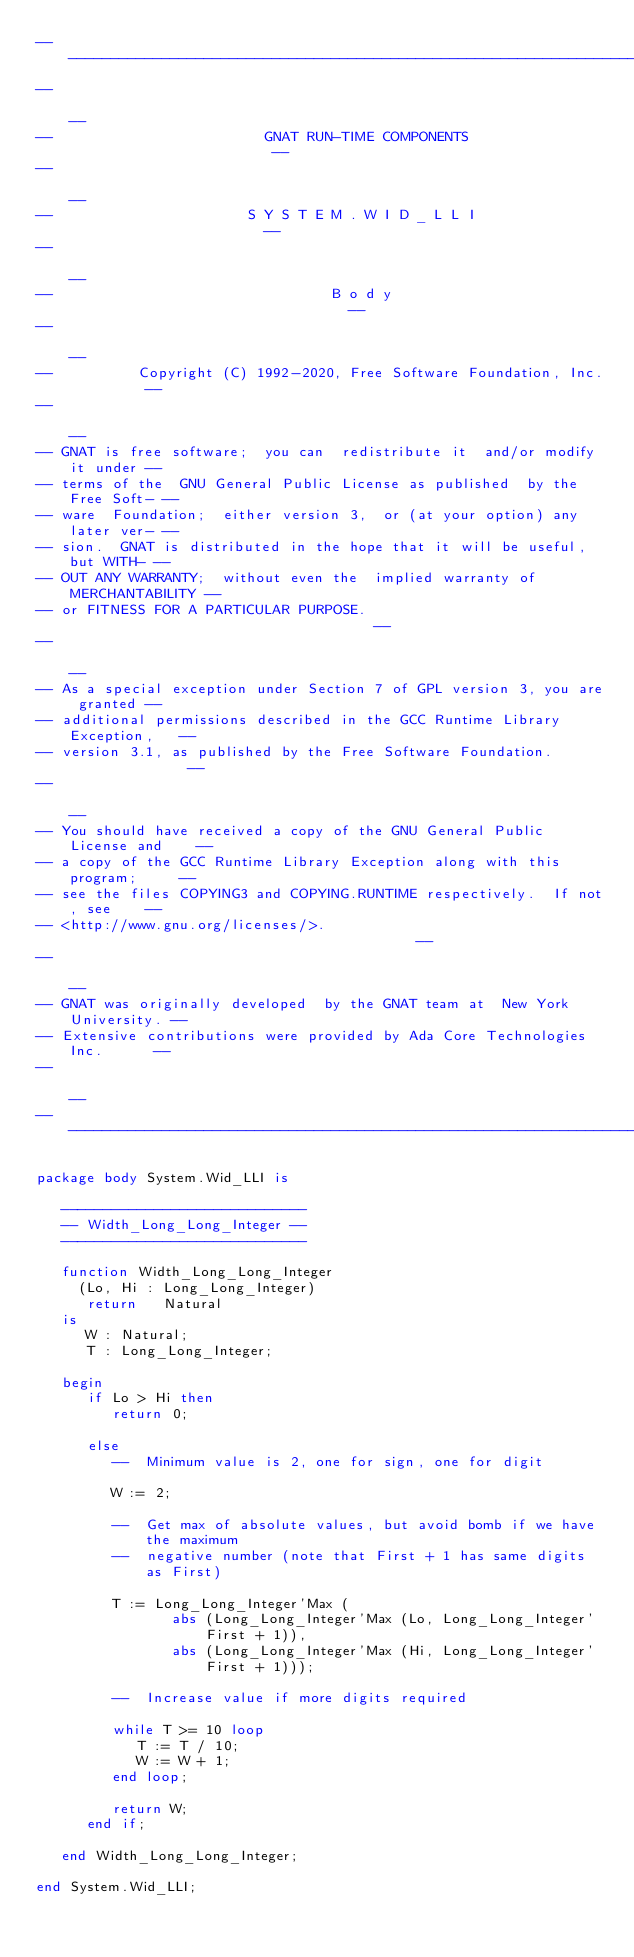Convert code to text. <code><loc_0><loc_0><loc_500><loc_500><_Ada_>------------------------------------------------------------------------------
--                                                                          --
--                         GNAT RUN-TIME COMPONENTS                         --
--                                                                          --
--                       S Y S T E M . W I D _ L L I                        --
--                                                                          --
--                                 B o d y                                  --
--                                                                          --
--          Copyright (C) 1992-2020, Free Software Foundation, Inc.         --
--                                                                          --
-- GNAT is free software;  you can  redistribute it  and/or modify it under --
-- terms of the  GNU General Public License as published  by the Free Soft- --
-- ware  Foundation;  either version 3,  or (at your option) any later ver- --
-- sion.  GNAT is distributed in the hope that it will be useful, but WITH- --
-- OUT ANY WARRANTY;  without even the  implied warranty of MERCHANTABILITY --
-- or FITNESS FOR A PARTICULAR PURPOSE.                                     --
--                                                                          --
-- As a special exception under Section 7 of GPL version 3, you are granted --
-- additional permissions described in the GCC Runtime Library Exception,   --
-- version 3.1, as published by the Free Software Foundation.               --
--                                                                          --
-- You should have received a copy of the GNU General Public License and    --
-- a copy of the GCC Runtime Library Exception along with this program;     --
-- see the files COPYING3 and COPYING.RUNTIME respectively.  If not, see    --
-- <http://www.gnu.org/licenses/>.                                          --
--                                                                          --
-- GNAT was originally developed  by the GNAT team at  New York University. --
-- Extensive contributions were provided by Ada Core Technologies Inc.      --
--                                                                          --
------------------------------------------------------------------------------

package body System.Wid_LLI is

   -----------------------------
   -- Width_Long_Long_Integer --
   -----------------------------

   function Width_Long_Long_Integer
     (Lo, Hi : Long_Long_Integer)
      return   Natural
   is
      W : Natural;
      T : Long_Long_Integer;

   begin
      if Lo > Hi then
         return 0;

      else
         --  Minimum value is 2, one for sign, one for digit

         W := 2;

         --  Get max of absolute values, but avoid bomb if we have the maximum
         --  negative number (note that First + 1 has same digits as First)

         T := Long_Long_Integer'Max (
                abs (Long_Long_Integer'Max (Lo, Long_Long_Integer'First + 1)),
                abs (Long_Long_Integer'Max (Hi, Long_Long_Integer'First + 1)));

         --  Increase value if more digits required

         while T >= 10 loop
            T := T / 10;
            W := W + 1;
         end loop;

         return W;
      end if;

   end Width_Long_Long_Integer;

end System.Wid_LLI;
</code> 